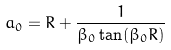Convert formula to latex. <formula><loc_0><loc_0><loc_500><loc_500>a _ { 0 } = R + \frac { 1 } { \beta _ { 0 } \tan ( \beta _ { 0 } R ) }</formula> 